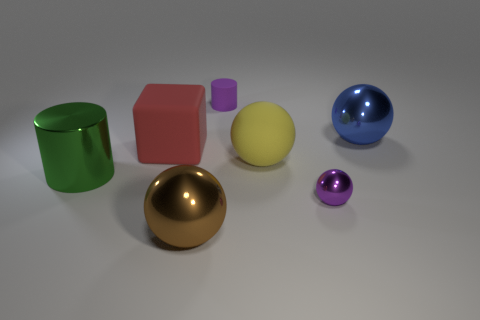What is the material of the purple object that is to the left of the yellow thing?
Ensure brevity in your answer.  Rubber. Do the green metal object and the tiny thing right of the tiny matte object have the same shape?
Provide a short and direct response. No. Are there more small yellow shiny objects than brown metallic spheres?
Ensure brevity in your answer.  No. Is there anything else that has the same color as the shiny cylinder?
Give a very brief answer. No. What is the shape of the big yellow thing that is the same material as the cube?
Make the answer very short. Sphere. What material is the cylinder on the right side of the thing to the left of the big red matte object?
Your response must be concise. Rubber. Do the tiny purple thing that is behind the big red cube and the green thing have the same shape?
Provide a short and direct response. Yes. Are there more large yellow rubber things on the right side of the big metallic cylinder than red metal spheres?
Give a very brief answer. Yes. There is a tiny metal thing that is the same color as the small rubber thing; what is its shape?
Make the answer very short. Sphere. How many blocks are either brown metallic objects or purple objects?
Give a very brief answer. 0. 